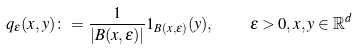Convert formula to latex. <formula><loc_0><loc_0><loc_500><loc_500>q _ { \varepsilon } ( x , y ) \colon = \frac { 1 } { | B ( x , \varepsilon ) | } 1 _ { B ( x , \varepsilon ) } ( y ) , \quad \varepsilon > 0 , x , y \in \mathbb { R } ^ { d }</formula> 